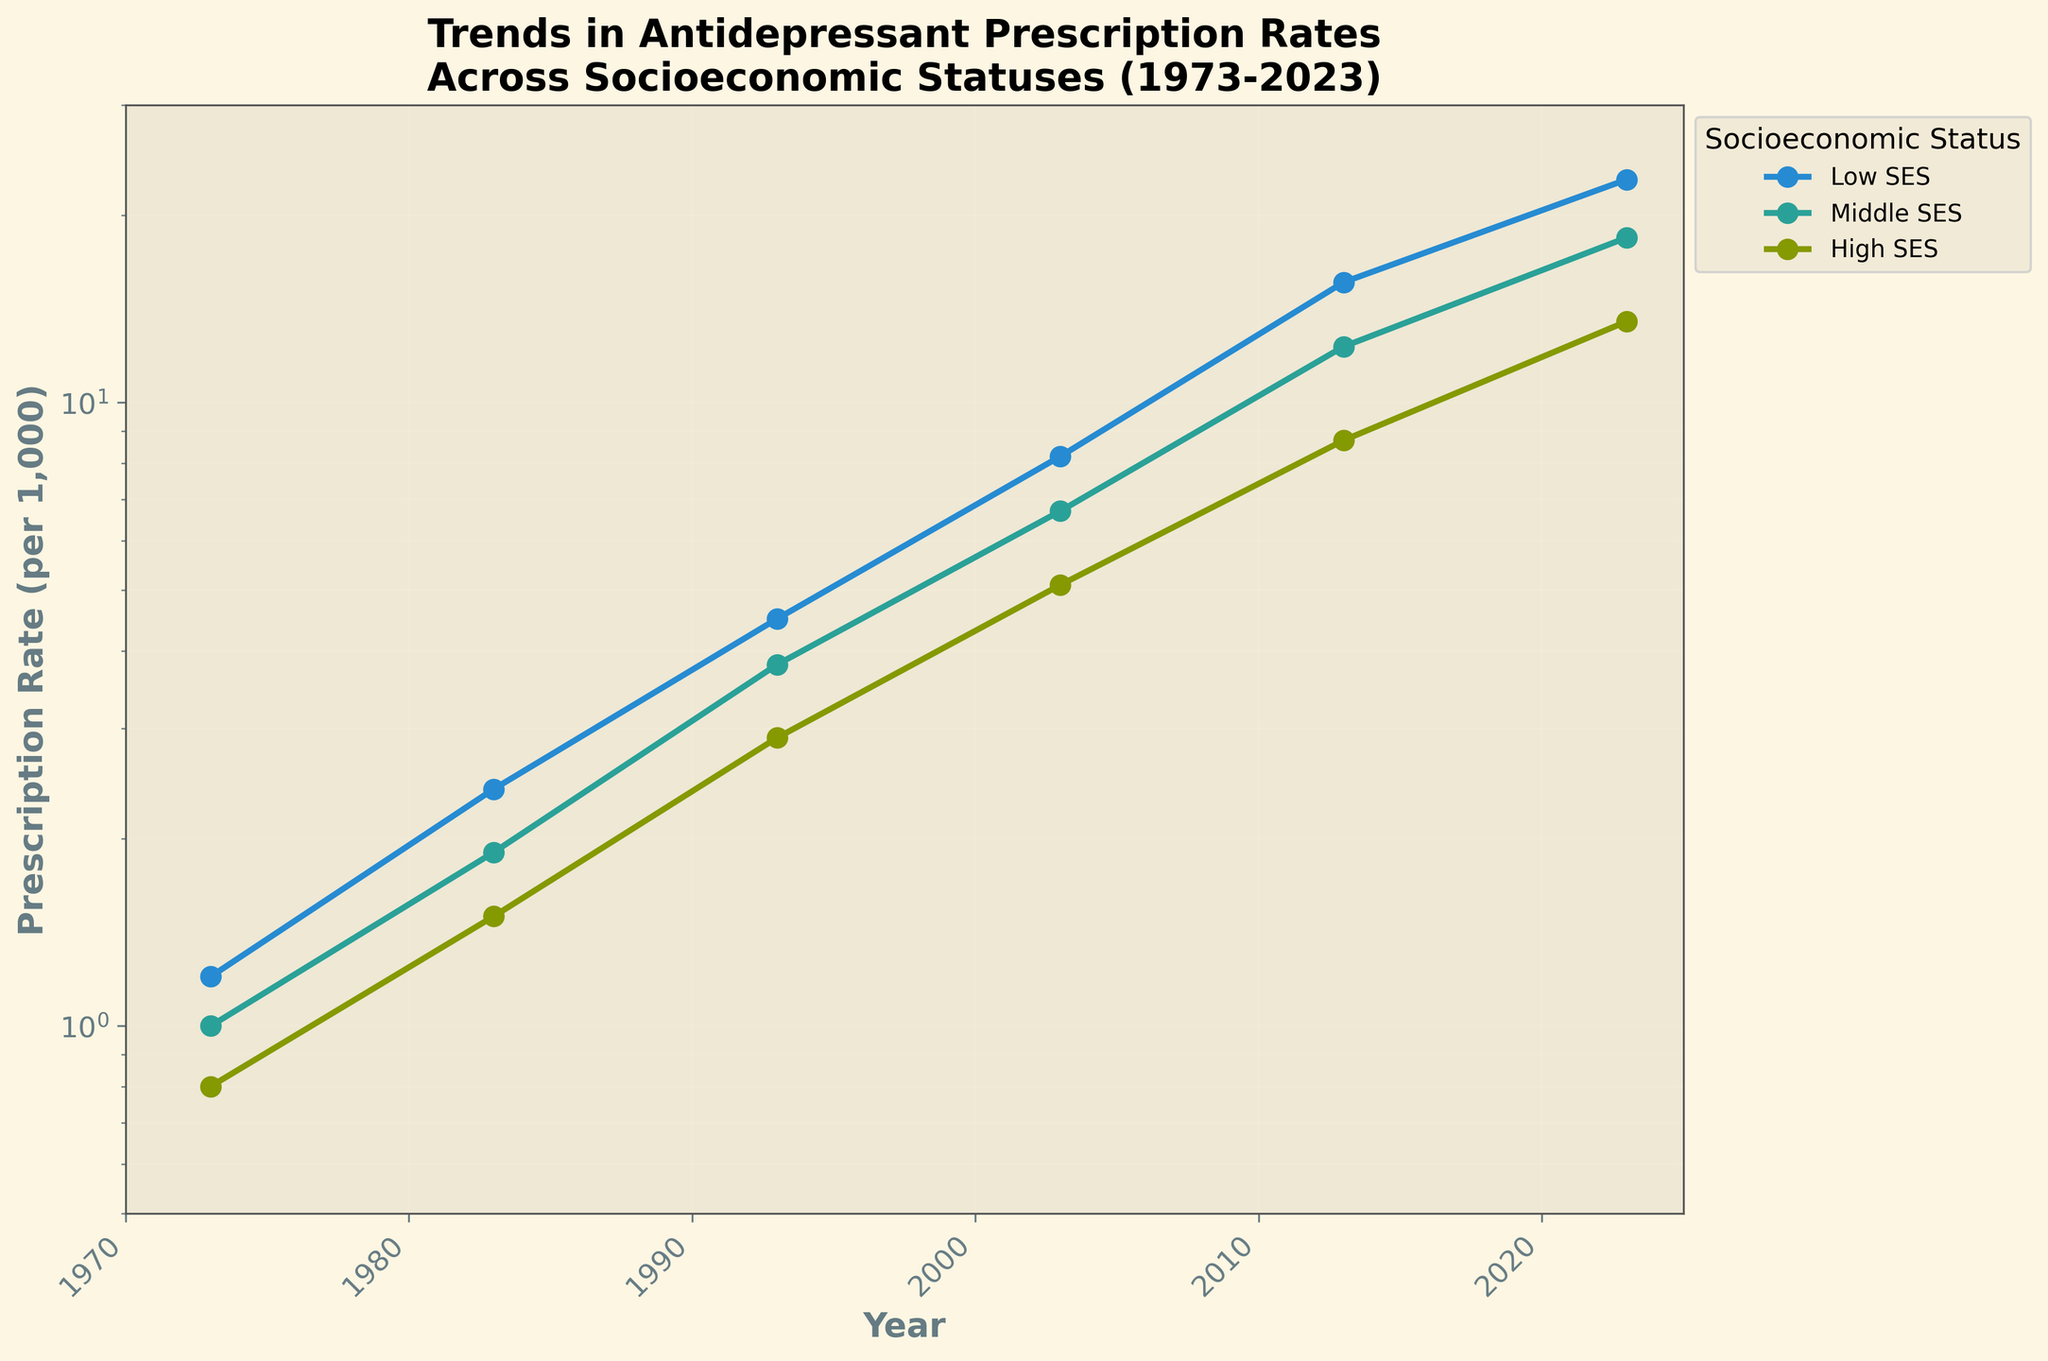What is the title of the plot? The title is located at the top of the plot.
Answer: Trends in Antidepressant Prescription Rates Across Socioeconomic Statuses (1973-2023) How many socioeconomic statuses are represented in the plot? The legend to the right of the plot labels the categories.
Answer: Three (Low, Middle, High) Which socioeconomic status had the highest prescription rate in 1973? Identify the lines on the plot and their markers for 1973.
Answer: Low By how much did the antidepressant prescription rate increase for the middle socioeconomic status from 1973 to 2023? Subtract the rate in 1973 from the rate in 2023 for the middle socioeconomic status.
Answer: 18.4 - 1.0 = 17.4 Which socioeconomic status had the steepest increase in prescription rates over the past 50 years? Compare the overall trends and slopes of the lines for each socioeconomic status.
Answer: Low At what year do the prescription rates start to significantly diverge between the high and low socioeconomic statuses? Look for the year when the lines for high and low statuses start to move apart markedly.
Answer: Around 1993 What was the prescription rate per 1000 people for the high socioeconomic status in 2003? Find the data point on the high socioeconomic status line for the year 2003.
Answer: 5.1 Is the trend of the prescription rates linear or exponential? Assess whether the lines on the log scale appear straight (indicative of an exponential trend).
Answer: Exponential Which socioeconomic status had the least variation in antidepressant prescription rates over the 50 years? Assess the relative stability of the lines, noting fluctuations or changes in each status.
Answer: High What is the prescription rate per 1000 for the low socioeconomic status in 2023? Find the data point on the low socioeconomic status line for the year 2023.
Answer: 22.8 